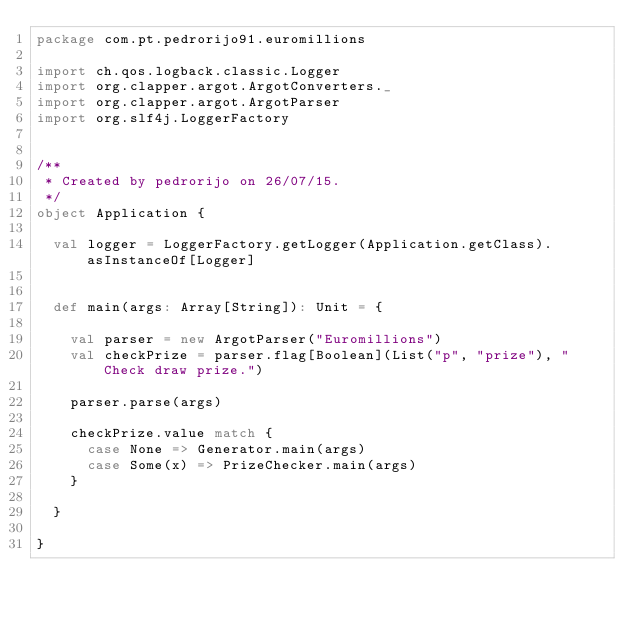<code> <loc_0><loc_0><loc_500><loc_500><_Scala_>package com.pt.pedrorijo91.euromillions

import ch.qos.logback.classic.Logger
import org.clapper.argot.ArgotConverters._
import org.clapper.argot.ArgotParser
import org.slf4j.LoggerFactory


/**
 * Created by pedrorijo on 26/07/15.
 */
object Application {

  val logger = LoggerFactory.getLogger(Application.getClass).asInstanceOf[Logger]


  def main(args: Array[String]): Unit = {

    val parser = new ArgotParser("Euromillions")
    val checkPrize = parser.flag[Boolean](List("p", "prize"), "Check draw prize.")

    parser.parse(args)

    checkPrize.value match {
      case None => Generator.main(args)
      case Some(x) => PrizeChecker.main(args)
    }

  }

}
</code> 